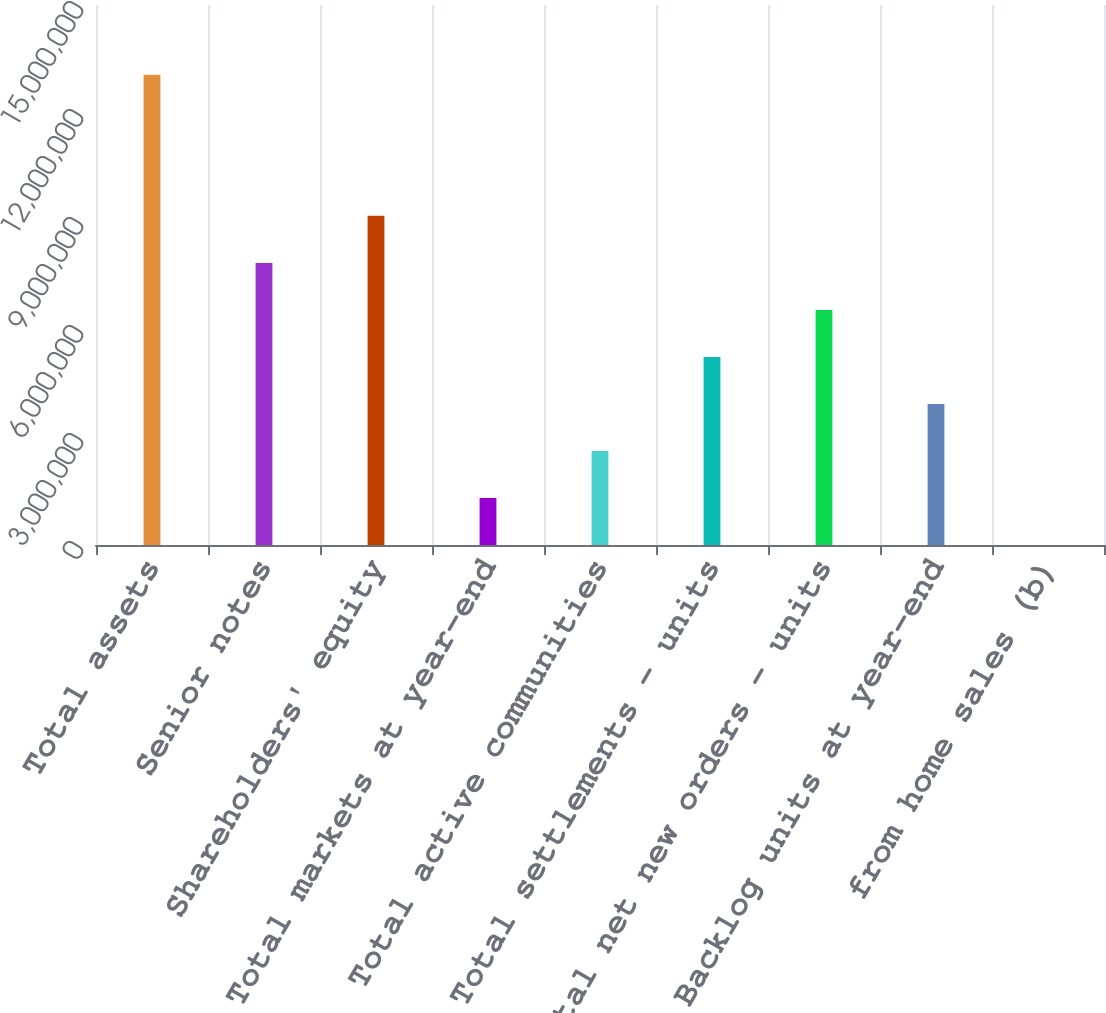Convert chart. <chart><loc_0><loc_0><loc_500><loc_500><bar_chart><fcel>Total assets<fcel>Senior notes<fcel>Shareholders' equity<fcel>Total markets at year-end<fcel>Total active communities<fcel>Total settlements - units<fcel>Total net new orders - units<fcel>Backlog units at year-end<fcel>from home sales (b)<nl><fcel>1.30609e+07<fcel>7.83653e+06<fcel>9.14261e+06<fcel>1.30611e+06<fcel>2.61219e+06<fcel>5.22436e+06<fcel>6.53044e+06<fcel>3.91827e+06<fcel>23.4<nl></chart> 